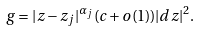<formula> <loc_0><loc_0><loc_500><loc_500>g = | z - z _ { j } | ^ { \alpha _ { j } } ( c + o ( 1 ) ) | d z | ^ { 2 } .</formula> 